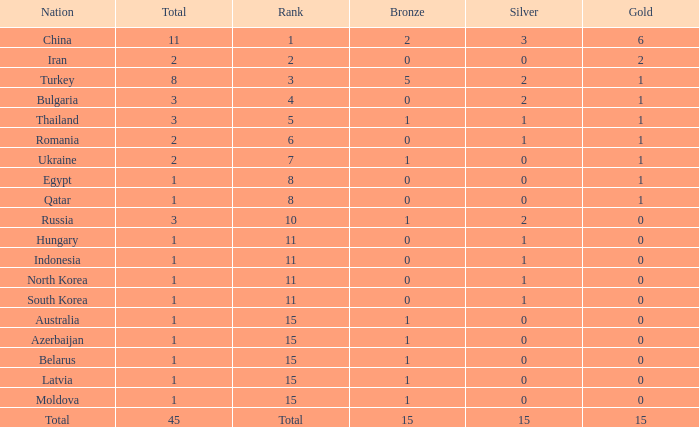What is the highest amount of bronze china, which has more than 1 gold and more than 11 total, has? None. 